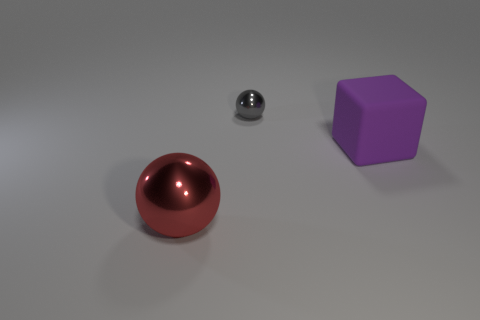Are there any other things that are the same size as the gray object?
Provide a succinct answer. No. There is a object that is the same size as the red metal ball; what is its color?
Your answer should be compact. Purple. How many big things are either blocks or objects?
Your response must be concise. 2. What material is the object that is to the left of the purple thing and in front of the tiny gray metal sphere?
Offer a terse response. Metal. There is a large object that is in front of the large purple matte thing; is it the same shape as the big purple rubber thing that is behind the red metal sphere?
Your answer should be compact. No. How many objects are either red shiny things that are to the left of the block or red things?
Ensure brevity in your answer.  1. Do the gray sphere and the purple rubber object have the same size?
Your answer should be very brief. No. There is a metal sphere in front of the small gray ball; what color is it?
Your response must be concise. Red. What is the size of the red sphere that is made of the same material as the gray ball?
Provide a succinct answer. Large. Do the purple block and the metallic sphere that is behind the large red ball have the same size?
Your answer should be very brief. No. 